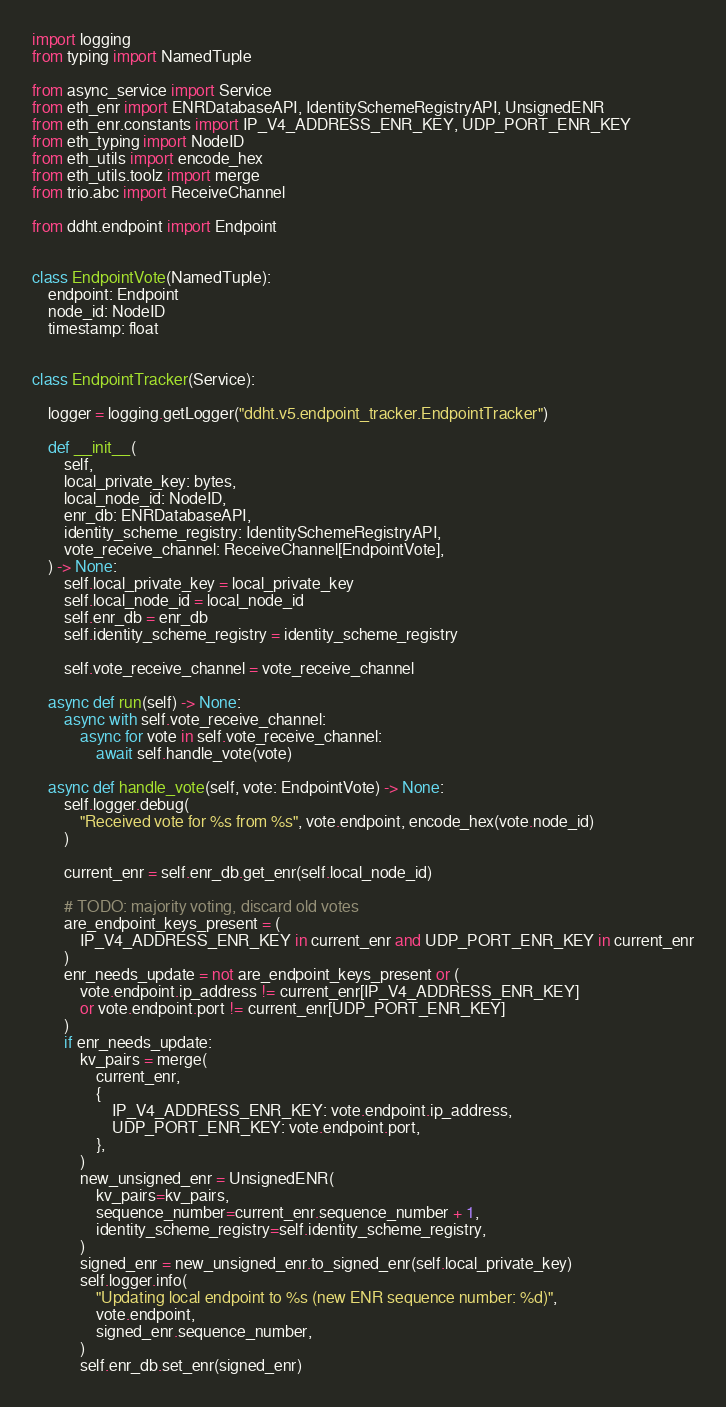<code> <loc_0><loc_0><loc_500><loc_500><_Python_>import logging
from typing import NamedTuple

from async_service import Service
from eth_enr import ENRDatabaseAPI, IdentitySchemeRegistryAPI, UnsignedENR
from eth_enr.constants import IP_V4_ADDRESS_ENR_KEY, UDP_PORT_ENR_KEY
from eth_typing import NodeID
from eth_utils import encode_hex
from eth_utils.toolz import merge
from trio.abc import ReceiveChannel

from ddht.endpoint import Endpoint


class EndpointVote(NamedTuple):
    endpoint: Endpoint
    node_id: NodeID
    timestamp: float


class EndpointTracker(Service):

    logger = logging.getLogger("ddht.v5.endpoint_tracker.EndpointTracker")

    def __init__(
        self,
        local_private_key: bytes,
        local_node_id: NodeID,
        enr_db: ENRDatabaseAPI,
        identity_scheme_registry: IdentitySchemeRegistryAPI,
        vote_receive_channel: ReceiveChannel[EndpointVote],
    ) -> None:
        self.local_private_key = local_private_key
        self.local_node_id = local_node_id
        self.enr_db = enr_db
        self.identity_scheme_registry = identity_scheme_registry

        self.vote_receive_channel = vote_receive_channel

    async def run(self) -> None:
        async with self.vote_receive_channel:
            async for vote in self.vote_receive_channel:
                await self.handle_vote(vote)

    async def handle_vote(self, vote: EndpointVote) -> None:
        self.logger.debug(
            "Received vote for %s from %s", vote.endpoint, encode_hex(vote.node_id)
        )

        current_enr = self.enr_db.get_enr(self.local_node_id)

        # TODO: majority voting, discard old votes
        are_endpoint_keys_present = (
            IP_V4_ADDRESS_ENR_KEY in current_enr and UDP_PORT_ENR_KEY in current_enr
        )
        enr_needs_update = not are_endpoint_keys_present or (
            vote.endpoint.ip_address != current_enr[IP_V4_ADDRESS_ENR_KEY]
            or vote.endpoint.port != current_enr[UDP_PORT_ENR_KEY]
        )
        if enr_needs_update:
            kv_pairs = merge(
                current_enr,
                {
                    IP_V4_ADDRESS_ENR_KEY: vote.endpoint.ip_address,
                    UDP_PORT_ENR_KEY: vote.endpoint.port,
                },
            )
            new_unsigned_enr = UnsignedENR(
                kv_pairs=kv_pairs,
                sequence_number=current_enr.sequence_number + 1,
                identity_scheme_registry=self.identity_scheme_registry,
            )
            signed_enr = new_unsigned_enr.to_signed_enr(self.local_private_key)
            self.logger.info(
                "Updating local endpoint to %s (new ENR sequence number: %d)",
                vote.endpoint,
                signed_enr.sequence_number,
            )
            self.enr_db.set_enr(signed_enr)
</code> 